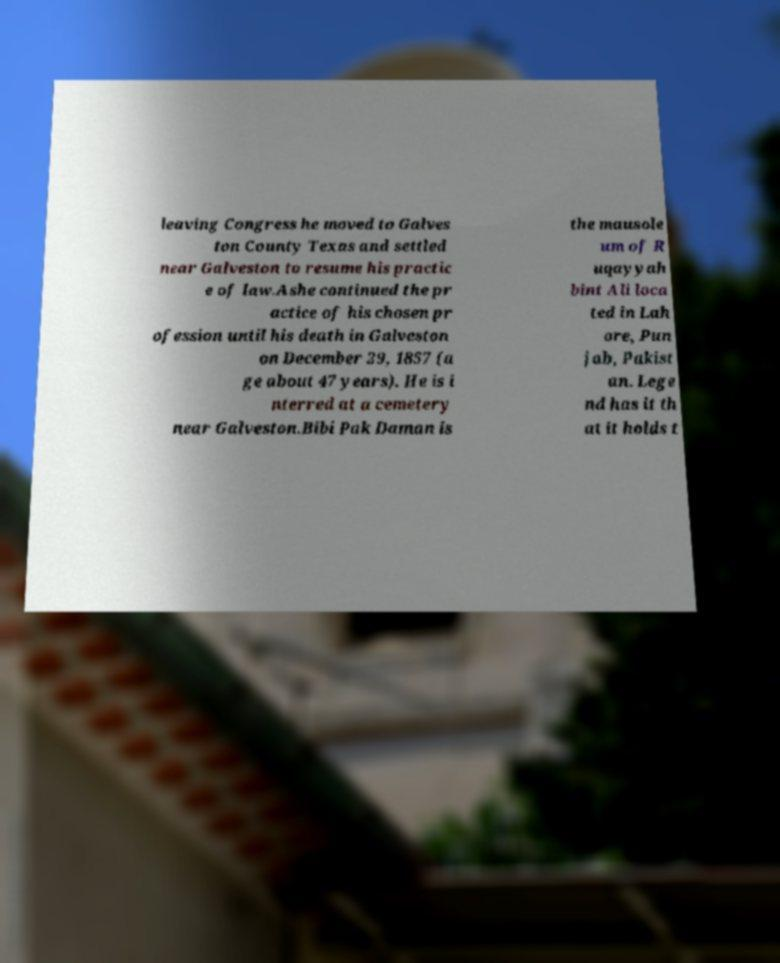For documentation purposes, I need the text within this image transcribed. Could you provide that? leaving Congress he moved to Galves ton County Texas and settled near Galveston to resume his practic e of law.Ashe continued the pr actice of his chosen pr ofession until his death in Galveston on December 29, 1857 (a ge about 47 years). He is i nterred at a cemetery near Galveston.Bibi Pak Daman is the mausole um of R uqayyah bint Ali loca ted in Lah ore, Pun jab, Pakist an. Lege nd has it th at it holds t 